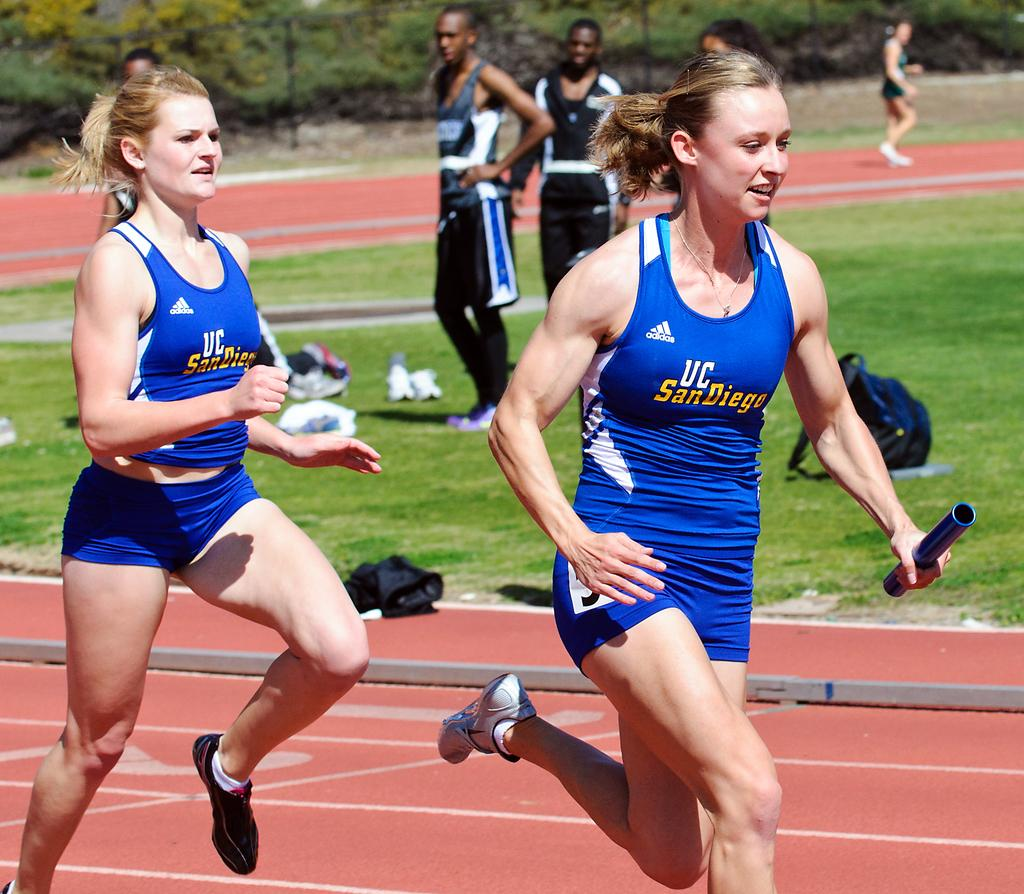<image>
Give a short and clear explanation of the subsequent image. Female runners from UC San Diego on a track with 2 male runners watching. 